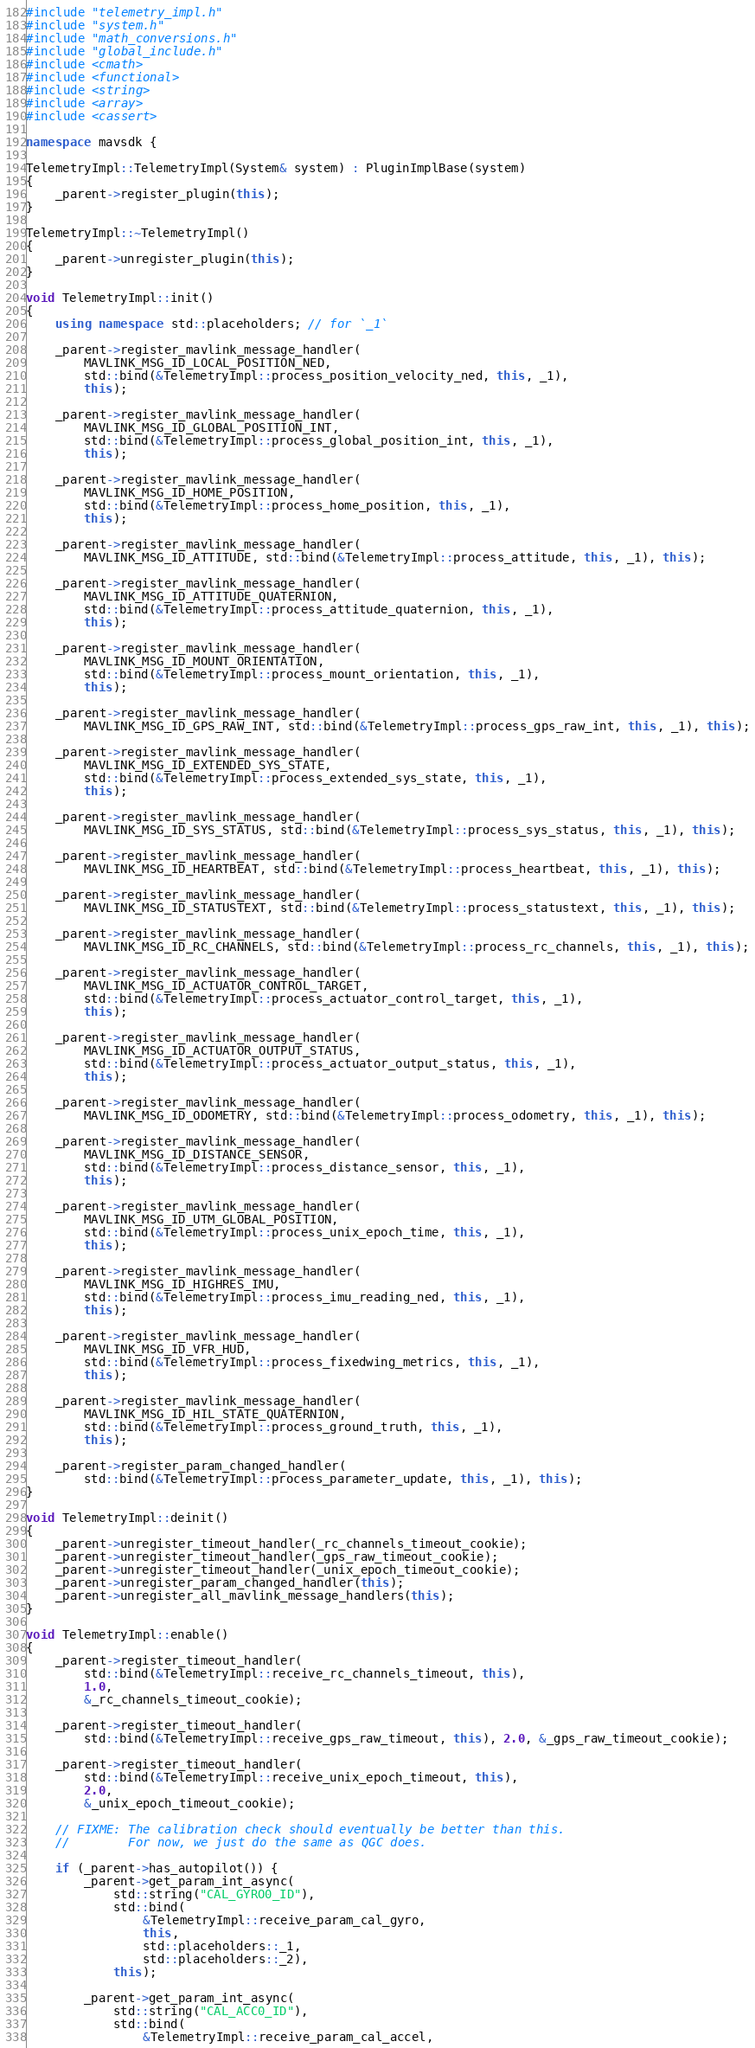Convert code to text. <code><loc_0><loc_0><loc_500><loc_500><_C++_>#include "telemetry_impl.h"
#include "system.h"
#include "math_conversions.h"
#include "global_include.h"
#include <cmath>
#include <functional>
#include <string>
#include <array>
#include <cassert>

namespace mavsdk {

TelemetryImpl::TelemetryImpl(System& system) : PluginImplBase(system)
{
    _parent->register_plugin(this);
}

TelemetryImpl::~TelemetryImpl()
{
    _parent->unregister_plugin(this);
}

void TelemetryImpl::init()
{
    using namespace std::placeholders; // for `_1`

    _parent->register_mavlink_message_handler(
        MAVLINK_MSG_ID_LOCAL_POSITION_NED,
        std::bind(&TelemetryImpl::process_position_velocity_ned, this, _1),
        this);

    _parent->register_mavlink_message_handler(
        MAVLINK_MSG_ID_GLOBAL_POSITION_INT,
        std::bind(&TelemetryImpl::process_global_position_int, this, _1),
        this);

    _parent->register_mavlink_message_handler(
        MAVLINK_MSG_ID_HOME_POSITION,
        std::bind(&TelemetryImpl::process_home_position, this, _1),
        this);

    _parent->register_mavlink_message_handler(
        MAVLINK_MSG_ID_ATTITUDE, std::bind(&TelemetryImpl::process_attitude, this, _1), this);

    _parent->register_mavlink_message_handler(
        MAVLINK_MSG_ID_ATTITUDE_QUATERNION,
        std::bind(&TelemetryImpl::process_attitude_quaternion, this, _1),
        this);

    _parent->register_mavlink_message_handler(
        MAVLINK_MSG_ID_MOUNT_ORIENTATION,
        std::bind(&TelemetryImpl::process_mount_orientation, this, _1),
        this);

    _parent->register_mavlink_message_handler(
        MAVLINK_MSG_ID_GPS_RAW_INT, std::bind(&TelemetryImpl::process_gps_raw_int, this, _1), this);

    _parent->register_mavlink_message_handler(
        MAVLINK_MSG_ID_EXTENDED_SYS_STATE,
        std::bind(&TelemetryImpl::process_extended_sys_state, this, _1),
        this);

    _parent->register_mavlink_message_handler(
        MAVLINK_MSG_ID_SYS_STATUS, std::bind(&TelemetryImpl::process_sys_status, this, _1), this);

    _parent->register_mavlink_message_handler(
        MAVLINK_MSG_ID_HEARTBEAT, std::bind(&TelemetryImpl::process_heartbeat, this, _1), this);

    _parent->register_mavlink_message_handler(
        MAVLINK_MSG_ID_STATUSTEXT, std::bind(&TelemetryImpl::process_statustext, this, _1), this);

    _parent->register_mavlink_message_handler(
        MAVLINK_MSG_ID_RC_CHANNELS, std::bind(&TelemetryImpl::process_rc_channels, this, _1), this);

    _parent->register_mavlink_message_handler(
        MAVLINK_MSG_ID_ACTUATOR_CONTROL_TARGET,
        std::bind(&TelemetryImpl::process_actuator_control_target, this, _1),
        this);

    _parent->register_mavlink_message_handler(
        MAVLINK_MSG_ID_ACTUATOR_OUTPUT_STATUS,
        std::bind(&TelemetryImpl::process_actuator_output_status, this, _1),
        this);

    _parent->register_mavlink_message_handler(
        MAVLINK_MSG_ID_ODOMETRY, std::bind(&TelemetryImpl::process_odometry, this, _1), this);

    _parent->register_mavlink_message_handler(
        MAVLINK_MSG_ID_DISTANCE_SENSOR,
        std::bind(&TelemetryImpl::process_distance_sensor, this, _1),
        this);

    _parent->register_mavlink_message_handler(
        MAVLINK_MSG_ID_UTM_GLOBAL_POSITION,
        std::bind(&TelemetryImpl::process_unix_epoch_time, this, _1),
        this);

    _parent->register_mavlink_message_handler(
        MAVLINK_MSG_ID_HIGHRES_IMU,
        std::bind(&TelemetryImpl::process_imu_reading_ned, this, _1),
        this);

    _parent->register_mavlink_message_handler(
        MAVLINK_MSG_ID_VFR_HUD,
        std::bind(&TelemetryImpl::process_fixedwing_metrics, this, _1),
        this);

    _parent->register_mavlink_message_handler(
        MAVLINK_MSG_ID_HIL_STATE_QUATERNION,
        std::bind(&TelemetryImpl::process_ground_truth, this, _1),
        this);

    _parent->register_param_changed_handler(
        std::bind(&TelemetryImpl::process_parameter_update, this, _1), this);
}

void TelemetryImpl::deinit()
{
    _parent->unregister_timeout_handler(_rc_channels_timeout_cookie);
    _parent->unregister_timeout_handler(_gps_raw_timeout_cookie);
    _parent->unregister_timeout_handler(_unix_epoch_timeout_cookie);
    _parent->unregister_param_changed_handler(this);
    _parent->unregister_all_mavlink_message_handlers(this);
}

void TelemetryImpl::enable()
{
    _parent->register_timeout_handler(
        std::bind(&TelemetryImpl::receive_rc_channels_timeout, this),
        1.0,
        &_rc_channels_timeout_cookie);

    _parent->register_timeout_handler(
        std::bind(&TelemetryImpl::receive_gps_raw_timeout, this), 2.0, &_gps_raw_timeout_cookie);

    _parent->register_timeout_handler(
        std::bind(&TelemetryImpl::receive_unix_epoch_timeout, this),
        2.0,
        &_unix_epoch_timeout_cookie);

    // FIXME: The calibration check should eventually be better than this.
    //        For now, we just do the same as QGC does.

    if (_parent->has_autopilot()) {
        _parent->get_param_int_async(
            std::string("CAL_GYRO0_ID"),
            std::bind(
                &TelemetryImpl::receive_param_cal_gyro,
                this,
                std::placeholders::_1,
                std::placeholders::_2),
            this);

        _parent->get_param_int_async(
            std::string("CAL_ACC0_ID"),
            std::bind(
                &TelemetryImpl::receive_param_cal_accel,</code> 